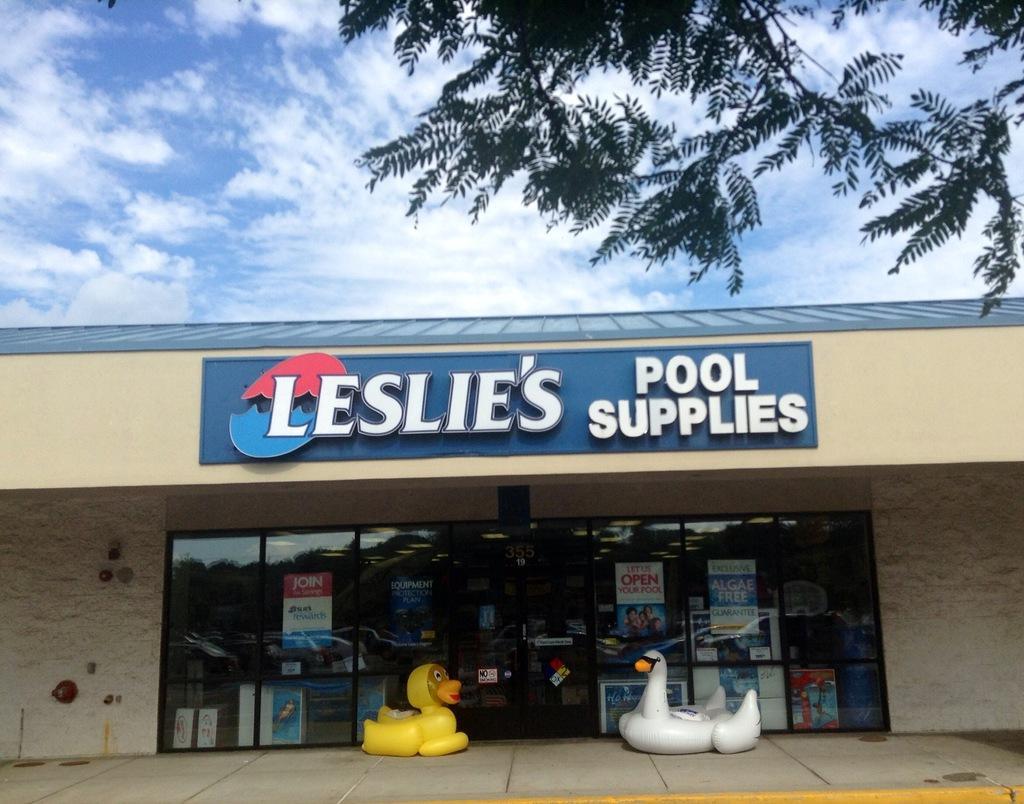Could you give a brief overview of what you see in this image? In this image we can see the entrance of Leslie's house with pool supplies. We can also see the toys on the path. At the top we can see the sky with clouds. We can also see the tree. 